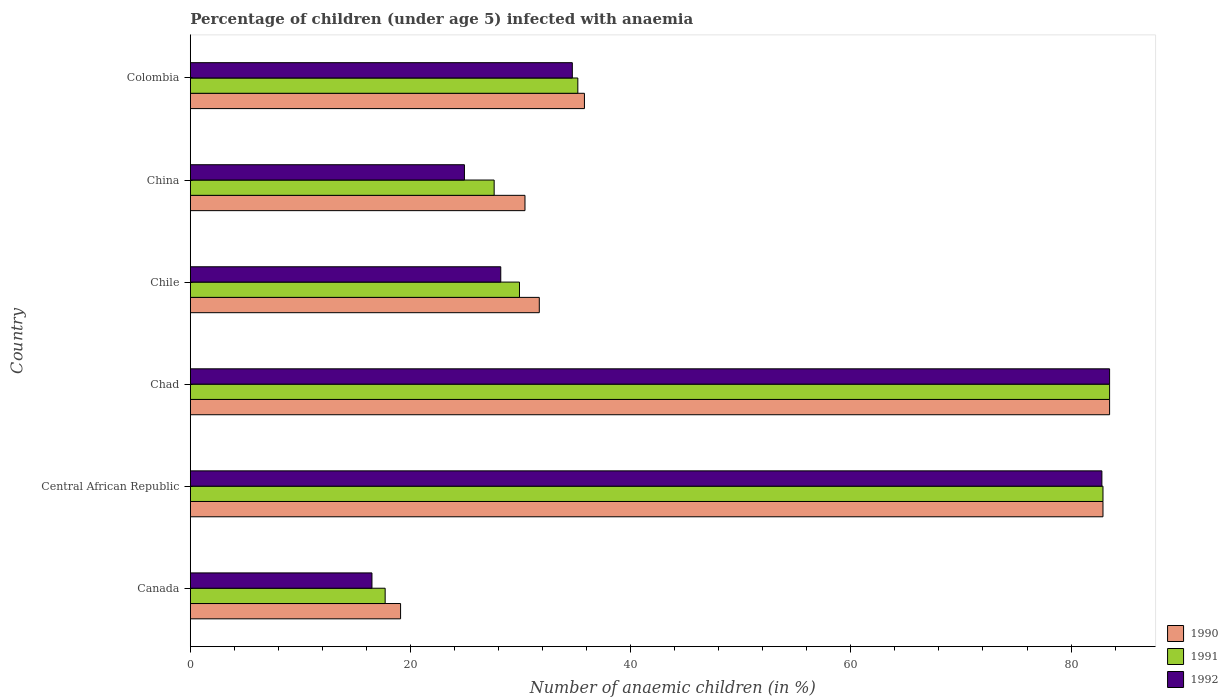How many different coloured bars are there?
Your answer should be compact. 3. How many groups of bars are there?
Provide a succinct answer. 6. What is the label of the 1st group of bars from the top?
Offer a very short reply. Colombia. In how many cases, is the number of bars for a given country not equal to the number of legend labels?
Provide a short and direct response. 0. What is the percentage of children infected with anaemia in in 1991 in Canada?
Make the answer very short. 17.7. Across all countries, what is the maximum percentage of children infected with anaemia in in 1992?
Keep it short and to the point. 83.5. In which country was the percentage of children infected with anaemia in in 1992 maximum?
Your response must be concise. Chad. What is the total percentage of children infected with anaemia in in 1991 in the graph?
Provide a succinct answer. 276.8. What is the difference between the percentage of children infected with anaemia in in 1990 in Central African Republic and that in Chile?
Your response must be concise. 51.2. What is the difference between the percentage of children infected with anaemia in in 1990 in Central African Republic and the percentage of children infected with anaemia in in 1991 in Chile?
Offer a terse response. 53. What is the average percentage of children infected with anaemia in in 1992 per country?
Ensure brevity in your answer.  45.1. What is the difference between the percentage of children infected with anaemia in in 1990 and percentage of children infected with anaemia in in 1992 in Colombia?
Offer a terse response. 1.1. In how many countries, is the percentage of children infected with anaemia in in 1992 greater than 68 %?
Offer a very short reply. 2. What is the ratio of the percentage of children infected with anaemia in in 1990 in Canada to that in Central African Republic?
Provide a short and direct response. 0.23. What is the difference between the highest and the second highest percentage of children infected with anaemia in in 1991?
Provide a short and direct response. 0.6. Is the sum of the percentage of children infected with anaemia in in 1990 in Chile and China greater than the maximum percentage of children infected with anaemia in in 1992 across all countries?
Provide a succinct answer. No. Is it the case that in every country, the sum of the percentage of children infected with anaemia in in 1991 and percentage of children infected with anaemia in in 1992 is greater than the percentage of children infected with anaemia in in 1990?
Offer a very short reply. Yes. How many bars are there?
Provide a short and direct response. 18. Are all the bars in the graph horizontal?
Offer a terse response. Yes. What is the difference between two consecutive major ticks on the X-axis?
Make the answer very short. 20. Are the values on the major ticks of X-axis written in scientific E-notation?
Your response must be concise. No. Does the graph contain any zero values?
Ensure brevity in your answer.  No. Does the graph contain grids?
Your answer should be compact. No. How many legend labels are there?
Make the answer very short. 3. How are the legend labels stacked?
Give a very brief answer. Vertical. What is the title of the graph?
Your answer should be compact. Percentage of children (under age 5) infected with anaemia. Does "2001" appear as one of the legend labels in the graph?
Your answer should be very brief. No. What is the label or title of the X-axis?
Your answer should be very brief. Number of anaemic children (in %). What is the Number of anaemic children (in %) in 1991 in Canada?
Provide a succinct answer. 17.7. What is the Number of anaemic children (in %) of 1992 in Canada?
Provide a short and direct response. 16.5. What is the Number of anaemic children (in %) of 1990 in Central African Republic?
Make the answer very short. 82.9. What is the Number of anaemic children (in %) in 1991 in Central African Republic?
Ensure brevity in your answer.  82.9. What is the Number of anaemic children (in %) in 1992 in Central African Republic?
Provide a succinct answer. 82.8. What is the Number of anaemic children (in %) in 1990 in Chad?
Offer a very short reply. 83.5. What is the Number of anaemic children (in %) of 1991 in Chad?
Provide a short and direct response. 83.5. What is the Number of anaemic children (in %) of 1992 in Chad?
Provide a succinct answer. 83.5. What is the Number of anaemic children (in %) in 1990 in Chile?
Your response must be concise. 31.7. What is the Number of anaemic children (in %) of 1991 in Chile?
Keep it short and to the point. 29.9. What is the Number of anaemic children (in %) of 1992 in Chile?
Your answer should be very brief. 28.2. What is the Number of anaemic children (in %) in 1990 in China?
Your answer should be very brief. 30.4. What is the Number of anaemic children (in %) in 1991 in China?
Your answer should be very brief. 27.6. What is the Number of anaemic children (in %) in 1992 in China?
Your answer should be very brief. 24.9. What is the Number of anaemic children (in %) of 1990 in Colombia?
Your answer should be very brief. 35.8. What is the Number of anaemic children (in %) of 1991 in Colombia?
Provide a succinct answer. 35.2. What is the Number of anaemic children (in %) of 1992 in Colombia?
Offer a very short reply. 34.7. Across all countries, what is the maximum Number of anaemic children (in %) of 1990?
Make the answer very short. 83.5. Across all countries, what is the maximum Number of anaemic children (in %) in 1991?
Provide a succinct answer. 83.5. Across all countries, what is the maximum Number of anaemic children (in %) in 1992?
Ensure brevity in your answer.  83.5. Across all countries, what is the minimum Number of anaemic children (in %) of 1990?
Make the answer very short. 19.1. Across all countries, what is the minimum Number of anaemic children (in %) in 1991?
Provide a short and direct response. 17.7. Across all countries, what is the minimum Number of anaemic children (in %) of 1992?
Your answer should be very brief. 16.5. What is the total Number of anaemic children (in %) in 1990 in the graph?
Offer a terse response. 283.4. What is the total Number of anaemic children (in %) in 1991 in the graph?
Provide a short and direct response. 276.8. What is the total Number of anaemic children (in %) in 1992 in the graph?
Provide a short and direct response. 270.6. What is the difference between the Number of anaemic children (in %) of 1990 in Canada and that in Central African Republic?
Provide a short and direct response. -63.8. What is the difference between the Number of anaemic children (in %) of 1991 in Canada and that in Central African Republic?
Your response must be concise. -65.2. What is the difference between the Number of anaemic children (in %) in 1992 in Canada and that in Central African Republic?
Offer a very short reply. -66.3. What is the difference between the Number of anaemic children (in %) in 1990 in Canada and that in Chad?
Your answer should be compact. -64.4. What is the difference between the Number of anaemic children (in %) of 1991 in Canada and that in Chad?
Offer a very short reply. -65.8. What is the difference between the Number of anaemic children (in %) in 1992 in Canada and that in Chad?
Keep it short and to the point. -67. What is the difference between the Number of anaemic children (in %) in 1992 in Canada and that in China?
Provide a succinct answer. -8.4. What is the difference between the Number of anaemic children (in %) in 1990 in Canada and that in Colombia?
Your answer should be very brief. -16.7. What is the difference between the Number of anaemic children (in %) of 1991 in Canada and that in Colombia?
Your answer should be very brief. -17.5. What is the difference between the Number of anaemic children (in %) of 1992 in Canada and that in Colombia?
Offer a very short reply. -18.2. What is the difference between the Number of anaemic children (in %) in 1990 in Central African Republic and that in Chad?
Provide a succinct answer. -0.6. What is the difference between the Number of anaemic children (in %) in 1991 in Central African Republic and that in Chad?
Your answer should be compact. -0.6. What is the difference between the Number of anaemic children (in %) of 1990 in Central African Republic and that in Chile?
Keep it short and to the point. 51.2. What is the difference between the Number of anaemic children (in %) in 1992 in Central African Republic and that in Chile?
Keep it short and to the point. 54.6. What is the difference between the Number of anaemic children (in %) in 1990 in Central African Republic and that in China?
Ensure brevity in your answer.  52.5. What is the difference between the Number of anaemic children (in %) in 1991 in Central African Republic and that in China?
Provide a short and direct response. 55.3. What is the difference between the Number of anaemic children (in %) in 1992 in Central African Republic and that in China?
Provide a short and direct response. 57.9. What is the difference between the Number of anaemic children (in %) in 1990 in Central African Republic and that in Colombia?
Your answer should be very brief. 47.1. What is the difference between the Number of anaemic children (in %) of 1991 in Central African Republic and that in Colombia?
Your response must be concise. 47.7. What is the difference between the Number of anaemic children (in %) in 1992 in Central African Republic and that in Colombia?
Your answer should be compact. 48.1. What is the difference between the Number of anaemic children (in %) in 1990 in Chad and that in Chile?
Your answer should be compact. 51.8. What is the difference between the Number of anaemic children (in %) of 1991 in Chad and that in Chile?
Provide a succinct answer. 53.6. What is the difference between the Number of anaemic children (in %) of 1992 in Chad and that in Chile?
Your answer should be very brief. 55.3. What is the difference between the Number of anaemic children (in %) of 1990 in Chad and that in China?
Keep it short and to the point. 53.1. What is the difference between the Number of anaemic children (in %) of 1991 in Chad and that in China?
Give a very brief answer. 55.9. What is the difference between the Number of anaemic children (in %) of 1992 in Chad and that in China?
Your answer should be compact. 58.6. What is the difference between the Number of anaemic children (in %) of 1990 in Chad and that in Colombia?
Ensure brevity in your answer.  47.7. What is the difference between the Number of anaemic children (in %) of 1991 in Chad and that in Colombia?
Provide a succinct answer. 48.3. What is the difference between the Number of anaemic children (in %) in 1992 in Chad and that in Colombia?
Keep it short and to the point. 48.8. What is the difference between the Number of anaemic children (in %) of 1992 in Chile and that in China?
Offer a terse response. 3.3. What is the difference between the Number of anaemic children (in %) of 1991 in Chile and that in Colombia?
Your answer should be compact. -5.3. What is the difference between the Number of anaemic children (in %) of 1990 in China and that in Colombia?
Your response must be concise. -5.4. What is the difference between the Number of anaemic children (in %) of 1991 in China and that in Colombia?
Ensure brevity in your answer.  -7.6. What is the difference between the Number of anaemic children (in %) of 1992 in China and that in Colombia?
Your answer should be very brief. -9.8. What is the difference between the Number of anaemic children (in %) in 1990 in Canada and the Number of anaemic children (in %) in 1991 in Central African Republic?
Make the answer very short. -63.8. What is the difference between the Number of anaemic children (in %) in 1990 in Canada and the Number of anaemic children (in %) in 1992 in Central African Republic?
Provide a succinct answer. -63.7. What is the difference between the Number of anaemic children (in %) in 1991 in Canada and the Number of anaemic children (in %) in 1992 in Central African Republic?
Ensure brevity in your answer.  -65.1. What is the difference between the Number of anaemic children (in %) in 1990 in Canada and the Number of anaemic children (in %) in 1991 in Chad?
Make the answer very short. -64.4. What is the difference between the Number of anaemic children (in %) in 1990 in Canada and the Number of anaemic children (in %) in 1992 in Chad?
Offer a terse response. -64.4. What is the difference between the Number of anaemic children (in %) of 1991 in Canada and the Number of anaemic children (in %) of 1992 in Chad?
Provide a succinct answer. -65.8. What is the difference between the Number of anaemic children (in %) in 1991 in Canada and the Number of anaemic children (in %) in 1992 in Chile?
Your response must be concise. -10.5. What is the difference between the Number of anaemic children (in %) of 1990 in Canada and the Number of anaemic children (in %) of 1991 in Colombia?
Your answer should be compact. -16.1. What is the difference between the Number of anaemic children (in %) of 1990 in Canada and the Number of anaemic children (in %) of 1992 in Colombia?
Your answer should be compact. -15.6. What is the difference between the Number of anaemic children (in %) in 1991 in Canada and the Number of anaemic children (in %) in 1992 in Colombia?
Your answer should be compact. -17. What is the difference between the Number of anaemic children (in %) in 1990 in Central African Republic and the Number of anaemic children (in %) in 1991 in Chad?
Provide a succinct answer. -0.6. What is the difference between the Number of anaemic children (in %) in 1991 in Central African Republic and the Number of anaemic children (in %) in 1992 in Chad?
Provide a short and direct response. -0.6. What is the difference between the Number of anaemic children (in %) in 1990 in Central African Republic and the Number of anaemic children (in %) in 1992 in Chile?
Keep it short and to the point. 54.7. What is the difference between the Number of anaemic children (in %) in 1991 in Central African Republic and the Number of anaemic children (in %) in 1992 in Chile?
Provide a short and direct response. 54.7. What is the difference between the Number of anaemic children (in %) of 1990 in Central African Republic and the Number of anaemic children (in %) of 1991 in China?
Make the answer very short. 55.3. What is the difference between the Number of anaemic children (in %) of 1991 in Central African Republic and the Number of anaemic children (in %) of 1992 in China?
Your answer should be compact. 58. What is the difference between the Number of anaemic children (in %) of 1990 in Central African Republic and the Number of anaemic children (in %) of 1991 in Colombia?
Ensure brevity in your answer.  47.7. What is the difference between the Number of anaemic children (in %) of 1990 in Central African Republic and the Number of anaemic children (in %) of 1992 in Colombia?
Your response must be concise. 48.2. What is the difference between the Number of anaemic children (in %) of 1991 in Central African Republic and the Number of anaemic children (in %) of 1992 in Colombia?
Offer a very short reply. 48.2. What is the difference between the Number of anaemic children (in %) of 1990 in Chad and the Number of anaemic children (in %) of 1991 in Chile?
Offer a terse response. 53.6. What is the difference between the Number of anaemic children (in %) of 1990 in Chad and the Number of anaemic children (in %) of 1992 in Chile?
Your answer should be compact. 55.3. What is the difference between the Number of anaemic children (in %) in 1991 in Chad and the Number of anaemic children (in %) in 1992 in Chile?
Provide a succinct answer. 55.3. What is the difference between the Number of anaemic children (in %) in 1990 in Chad and the Number of anaemic children (in %) in 1991 in China?
Keep it short and to the point. 55.9. What is the difference between the Number of anaemic children (in %) in 1990 in Chad and the Number of anaemic children (in %) in 1992 in China?
Ensure brevity in your answer.  58.6. What is the difference between the Number of anaemic children (in %) of 1991 in Chad and the Number of anaemic children (in %) of 1992 in China?
Your response must be concise. 58.6. What is the difference between the Number of anaemic children (in %) in 1990 in Chad and the Number of anaemic children (in %) in 1991 in Colombia?
Your answer should be compact. 48.3. What is the difference between the Number of anaemic children (in %) of 1990 in Chad and the Number of anaemic children (in %) of 1992 in Colombia?
Your response must be concise. 48.8. What is the difference between the Number of anaemic children (in %) of 1991 in Chad and the Number of anaemic children (in %) of 1992 in Colombia?
Offer a terse response. 48.8. What is the difference between the Number of anaemic children (in %) in 1990 in Chile and the Number of anaemic children (in %) in 1991 in China?
Offer a very short reply. 4.1. What is the difference between the Number of anaemic children (in %) of 1990 in Chile and the Number of anaemic children (in %) of 1992 in China?
Your answer should be very brief. 6.8. What is the difference between the Number of anaemic children (in %) of 1991 in Chile and the Number of anaemic children (in %) of 1992 in China?
Provide a short and direct response. 5. What is the average Number of anaemic children (in %) of 1990 per country?
Ensure brevity in your answer.  47.23. What is the average Number of anaemic children (in %) in 1991 per country?
Provide a succinct answer. 46.13. What is the average Number of anaemic children (in %) of 1992 per country?
Offer a terse response. 45.1. What is the difference between the Number of anaemic children (in %) of 1990 and Number of anaemic children (in %) of 1991 in Canada?
Make the answer very short. 1.4. What is the difference between the Number of anaemic children (in %) of 1990 and Number of anaemic children (in %) of 1992 in Canada?
Keep it short and to the point. 2.6. What is the difference between the Number of anaemic children (in %) of 1991 and Number of anaemic children (in %) of 1992 in Canada?
Provide a succinct answer. 1.2. What is the difference between the Number of anaemic children (in %) of 1990 and Number of anaemic children (in %) of 1992 in Central African Republic?
Provide a short and direct response. 0.1. What is the difference between the Number of anaemic children (in %) of 1990 and Number of anaemic children (in %) of 1991 in Chile?
Your answer should be very brief. 1.8. What is the difference between the Number of anaemic children (in %) of 1990 and Number of anaemic children (in %) of 1992 in Chile?
Offer a terse response. 3.5. What is the difference between the Number of anaemic children (in %) of 1991 and Number of anaemic children (in %) of 1992 in Chile?
Keep it short and to the point. 1.7. What is the difference between the Number of anaemic children (in %) of 1990 and Number of anaemic children (in %) of 1991 in China?
Offer a very short reply. 2.8. What is the difference between the Number of anaemic children (in %) of 1991 and Number of anaemic children (in %) of 1992 in China?
Provide a short and direct response. 2.7. What is the difference between the Number of anaemic children (in %) of 1990 and Number of anaemic children (in %) of 1992 in Colombia?
Give a very brief answer. 1.1. What is the difference between the Number of anaemic children (in %) in 1991 and Number of anaemic children (in %) in 1992 in Colombia?
Provide a succinct answer. 0.5. What is the ratio of the Number of anaemic children (in %) in 1990 in Canada to that in Central African Republic?
Offer a terse response. 0.23. What is the ratio of the Number of anaemic children (in %) in 1991 in Canada to that in Central African Republic?
Offer a very short reply. 0.21. What is the ratio of the Number of anaemic children (in %) in 1992 in Canada to that in Central African Republic?
Make the answer very short. 0.2. What is the ratio of the Number of anaemic children (in %) in 1990 in Canada to that in Chad?
Offer a very short reply. 0.23. What is the ratio of the Number of anaemic children (in %) in 1991 in Canada to that in Chad?
Your answer should be compact. 0.21. What is the ratio of the Number of anaemic children (in %) in 1992 in Canada to that in Chad?
Make the answer very short. 0.2. What is the ratio of the Number of anaemic children (in %) of 1990 in Canada to that in Chile?
Make the answer very short. 0.6. What is the ratio of the Number of anaemic children (in %) in 1991 in Canada to that in Chile?
Your answer should be compact. 0.59. What is the ratio of the Number of anaemic children (in %) in 1992 in Canada to that in Chile?
Offer a very short reply. 0.59. What is the ratio of the Number of anaemic children (in %) of 1990 in Canada to that in China?
Make the answer very short. 0.63. What is the ratio of the Number of anaemic children (in %) in 1991 in Canada to that in China?
Your response must be concise. 0.64. What is the ratio of the Number of anaemic children (in %) in 1992 in Canada to that in China?
Keep it short and to the point. 0.66. What is the ratio of the Number of anaemic children (in %) in 1990 in Canada to that in Colombia?
Provide a succinct answer. 0.53. What is the ratio of the Number of anaemic children (in %) of 1991 in Canada to that in Colombia?
Keep it short and to the point. 0.5. What is the ratio of the Number of anaemic children (in %) of 1992 in Canada to that in Colombia?
Make the answer very short. 0.48. What is the ratio of the Number of anaemic children (in %) in 1990 in Central African Republic to that in Chile?
Your response must be concise. 2.62. What is the ratio of the Number of anaemic children (in %) of 1991 in Central African Republic to that in Chile?
Provide a succinct answer. 2.77. What is the ratio of the Number of anaemic children (in %) of 1992 in Central African Republic to that in Chile?
Ensure brevity in your answer.  2.94. What is the ratio of the Number of anaemic children (in %) of 1990 in Central African Republic to that in China?
Provide a short and direct response. 2.73. What is the ratio of the Number of anaemic children (in %) in 1991 in Central African Republic to that in China?
Offer a terse response. 3. What is the ratio of the Number of anaemic children (in %) in 1992 in Central African Republic to that in China?
Make the answer very short. 3.33. What is the ratio of the Number of anaemic children (in %) in 1990 in Central African Republic to that in Colombia?
Your response must be concise. 2.32. What is the ratio of the Number of anaemic children (in %) of 1991 in Central African Republic to that in Colombia?
Offer a very short reply. 2.36. What is the ratio of the Number of anaemic children (in %) of 1992 in Central African Republic to that in Colombia?
Offer a terse response. 2.39. What is the ratio of the Number of anaemic children (in %) of 1990 in Chad to that in Chile?
Provide a short and direct response. 2.63. What is the ratio of the Number of anaemic children (in %) in 1991 in Chad to that in Chile?
Your response must be concise. 2.79. What is the ratio of the Number of anaemic children (in %) of 1992 in Chad to that in Chile?
Offer a terse response. 2.96. What is the ratio of the Number of anaemic children (in %) in 1990 in Chad to that in China?
Your answer should be compact. 2.75. What is the ratio of the Number of anaemic children (in %) in 1991 in Chad to that in China?
Your answer should be very brief. 3.03. What is the ratio of the Number of anaemic children (in %) in 1992 in Chad to that in China?
Offer a terse response. 3.35. What is the ratio of the Number of anaemic children (in %) in 1990 in Chad to that in Colombia?
Give a very brief answer. 2.33. What is the ratio of the Number of anaemic children (in %) in 1991 in Chad to that in Colombia?
Provide a succinct answer. 2.37. What is the ratio of the Number of anaemic children (in %) in 1992 in Chad to that in Colombia?
Offer a terse response. 2.41. What is the ratio of the Number of anaemic children (in %) of 1990 in Chile to that in China?
Provide a short and direct response. 1.04. What is the ratio of the Number of anaemic children (in %) in 1992 in Chile to that in China?
Offer a very short reply. 1.13. What is the ratio of the Number of anaemic children (in %) in 1990 in Chile to that in Colombia?
Give a very brief answer. 0.89. What is the ratio of the Number of anaemic children (in %) in 1991 in Chile to that in Colombia?
Your answer should be compact. 0.85. What is the ratio of the Number of anaemic children (in %) in 1992 in Chile to that in Colombia?
Your answer should be very brief. 0.81. What is the ratio of the Number of anaemic children (in %) in 1990 in China to that in Colombia?
Your answer should be very brief. 0.85. What is the ratio of the Number of anaemic children (in %) of 1991 in China to that in Colombia?
Your answer should be very brief. 0.78. What is the ratio of the Number of anaemic children (in %) in 1992 in China to that in Colombia?
Keep it short and to the point. 0.72. What is the difference between the highest and the second highest Number of anaemic children (in %) of 1990?
Your answer should be very brief. 0.6. What is the difference between the highest and the second highest Number of anaemic children (in %) of 1992?
Offer a terse response. 0.7. What is the difference between the highest and the lowest Number of anaemic children (in %) in 1990?
Offer a very short reply. 64.4. What is the difference between the highest and the lowest Number of anaemic children (in %) of 1991?
Your response must be concise. 65.8. What is the difference between the highest and the lowest Number of anaemic children (in %) in 1992?
Offer a very short reply. 67. 